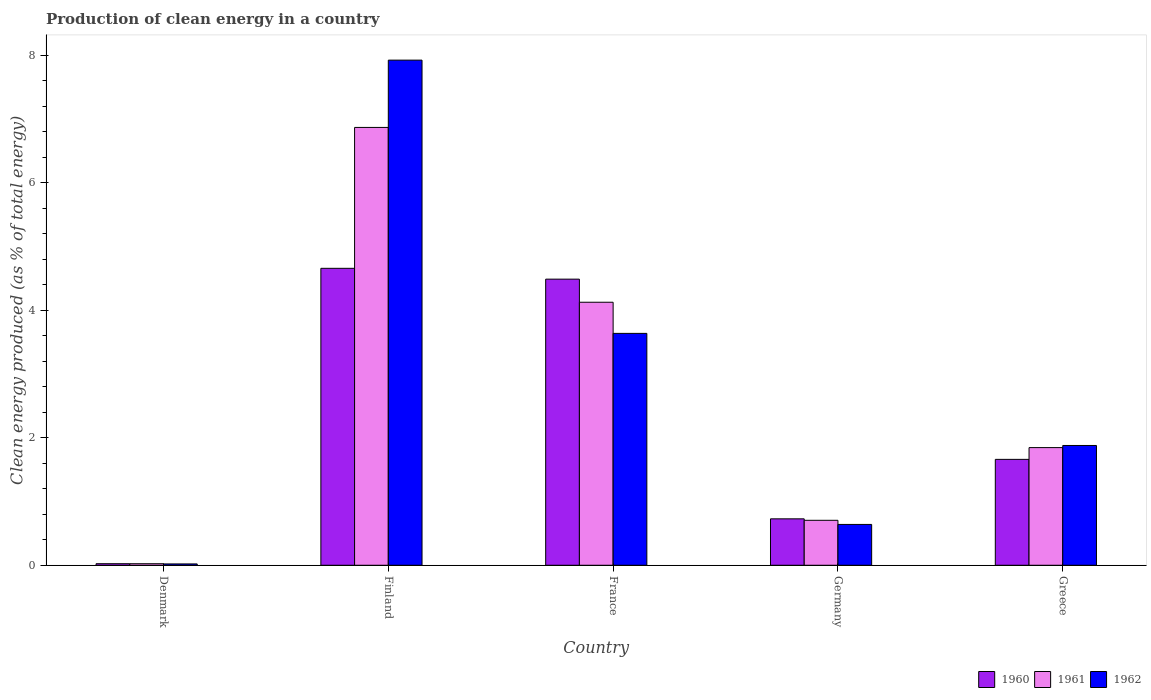Are the number of bars per tick equal to the number of legend labels?
Keep it short and to the point. Yes. How many bars are there on the 2nd tick from the right?
Make the answer very short. 3. What is the label of the 2nd group of bars from the left?
Offer a terse response. Finland. What is the percentage of clean energy produced in 1962 in Denmark?
Offer a terse response. 0.02. Across all countries, what is the maximum percentage of clean energy produced in 1961?
Your answer should be very brief. 6.87. Across all countries, what is the minimum percentage of clean energy produced in 1960?
Your response must be concise. 0.02. What is the total percentage of clean energy produced in 1962 in the graph?
Make the answer very short. 14.1. What is the difference between the percentage of clean energy produced in 1962 in France and that in Greece?
Your answer should be compact. 1.76. What is the difference between the percentage of clean energy produced in 1960 in Greece and the percentage of clean energy produced in 1962 in Denmark?
Keep it short and to the point. 1.64. What is the average percentage of clean energy produced in 1962 per country?
Make the answer very short. 2.82. What is the difference between the percentage of clean energy produced of/in 1960 and percentage of clean energy produced of/in 1962 in France?
Give a very brief answer. 0.85. In how many countries, is the percentage of clean energy produced in 1961 greater than 4.8 %?
Your response must be concise. 1. What is the ratio of the percentage of clean energy produced in 1961 in Denmark to that in Greece?
Your response must be concise. 0.01. What is the difference between the highest and the second highest percentage of clean energy produced in 1960?
Make the answer very short. -3. What is the difference between the highest and the lowest percentage of clean energy produced in 1962?
Offer a terse response. 7.9. Is the sum of the percentage of clean energy produced in 1962 in Finland and Germany greater than the maximum percentage of clean energy produced in 1960 across all countries?
Your response must be concise. Yes. What does the 1st bar from the right in Finland represents?
Offer a very short reply. 1962. How many bars are there?
Offer a terse response. 15. Are all the bars in the graph horizontal?
Keep it short and to the point. No. How many countries are there in the graph?
Your answer should be very brief. 5. Are the values on the major ticks of Y-axis written in scientific E-notation?
Your response must be concise. No. Does the graph contain grids?
Provide a short and direct response. No. Where does the legend appear in the graph?
Your answer should be very brief. Bottom right. How are the legend labels stacked?
Make the answer very short. Horizontal. What is the title of the graph?
Make the answer very short. Production of clean energy in a country. What is the label or title of the X-axis?
Provide a short and direct response. Country. What is the label or title of the Y-axis?
Your response must be concise. Clean energy produced (as % of total energy). What is the Clean energy produced (as % of total energy) in 1960 in Denmark?
Provide a succinct answer. 0.02. What is the Clean energy produced (as % of total energy) in 1961 in Denmark?
Keep it short and to the point. 0.02. What is the Clean energy produced (as % of total energy) of 1962 in Denmark?
Keep it short and to the point. 0.02. What is the Clean energy produced (as % of total energy) in 1960 in Finland?
Your response must be concise. 4.66. What is the Clean energy produced (as % of total energy) in 1961 in Finland?
Provide a succinct answer. 6.87. What is the Clean energy produced (as % of total energy) in 1962 in Finland?
Ensure brevity in your answer.  7.92. What is the Clean energy produced (as % of total energy) in 1960 in France?
Ensure brevity in your answer.  4.49. What is the Clean energy produced (as % of total energy) in 1961 in France?
Your answer should be very brief. 4.12. What is the Clean energy produced (as % of total energy) of 1962 in France?
Make the answer very short. 3.64. What is the Clean energy produced (as % of total energy) in 1960 in Germany?
Offer a terse response. 0.73. What is the Clean energy produced (as % of total energy) in 1961 in Germany?
Your response must be concise. 0.7. What is the Clean energy produced (as % of total energy) of 1962 in Germany?
Offer a very short reply. 0.64. What is the Clean energy produced (as % of total energy) of 1960 in Greece?
Make the answer very short. 1.66. What is the Clean energy produced (as % of total energy) of 1961 in Greece?
Give a very brief answer. 1.84. What is the Clean energy produced (as % of total energy) in 1962 in Greece?
Offer a terse response. 1.88. Across all countries, what is the maximum Clean energy produced (as % of total energy) in 1960?
Offer a terse response. 4.66. Across all countries, what is the maximum Clean energy produced (as % of total energy) in 1961?
Provide a short and direct response. 6.87. Across all countries, what is the maximum Clean energy produced (as % of total energy) of 1962?
Offer a very short reply. 7.92. Across all countries, what is the minimum Clean energy produced (as % of total energy) in 1960?
Make the answer very short. 0.02. Across all countries, what is the minimum Clean energy produced (as % of total energy) in 1961?
Make the answer very short. 0.02. Across all countries, what is the minimum Clean energy produced (as % of total energy) of 1962?
Give a very brief answer. 0.02. What is the total Clean energy produced (as % of total energy) in 1960 in the graph?
Keep it short and to the point. 11.56. What is the total Clean energy produced (as % of total energy) of 1961 in the graph?
Your response must be concise. 13.56. What is the total Clean energy produced (as % of total energy) of 1962 in the graph?
Provide a short and direct response. 14.1. What is the difference between the Clean energy produced (as % of total energy) of 1960 in Denmark and that in Finland?
Keep it short and to the point. -4.63. What is the difference between the Clean energy produced (as % of total energy) in 1961 in Denmark and that in Finland?
Provide a short and direct response. -6.84. What is the difference between the Clean energy produced (as % of total energy) in 1962 in Denmark and that in Finland?
Offer a very short reply. -7.9. What is the difference between the Clean energy produced (as % of total energy) in 1960 in Denmark and that in France?
Your response must be concise. -4.46. What is the difference between the Clean energy produced (as % of total energy) in 1961 in Denmark and that in France?
Give a very brief answer. -4.1. What is the difference between the Clean energy produced (as % of total energy) of 1962 in Denmark and that in France?
Your answer should be compact. -3.62. What is the difference between the Clean energy produced (as % of total energy) in 1960 in Denmark and that in Germany?
Make the answer very short. -0.7. What is the difference between the Clean energy produced (as % of total energy) of 1961 in Denmark and that in Germany?
Ensure brevity in your answer.  -0.68. What is the difference between the Clean energy produced (as % of total energy) of 1962 in Denmark and that in Germany?
Your answer should be compact. -0.62. What is the difference between the Clean energy produced (as % of total energy) of 1960 in Denmark and that in Greece?
Your answer should be compact. -1.64. What is the difference between the Clean energy produced (as % of total energy) in 1961 in Denmark and that in Greece?
Offer a terse response. -1.82. What is the difference between the Clean energy produced (as % of total energy) of 1962 in Denmark and that in Greece?
Provide a succinct answer. -1.86. What is the difference between the Clean energy produced (as % of total energy) of 1960 in Finland and that in France?
Your answer should be very brief. 0.17. What is the difference between the Clean energy produced (as % of total energy) in 1961 in Finland and that in France?
Your answer should be compact. 2.74. What is the difference between the Clean energy produced (as % of total energy) of 1962 in Finland and that in France?
Give a very brief answer. 4.28. What is the difference between the Clean energy produced (as % of total energy) of 1960 in Finland and that in Germany?
Your answer should be compact. 3.93. What is the difference between the Clean energy produced (as % of total energy) in 1961 in Finland and that in Germany?
Make the answer very short. 6.16. What is the difference between the Clean energy produced (as % of total energy) in 1962 in Finland and that in Germany?
Your answer should be very brief. 7.28. What is the difference between the Clean energy produced (as % of total energy) in 1960 in Finland and that in Greece?
Keep it short and to the point. 3. What is the difference between the Clean energy produced (as % of total energy) of 1961 in Finland and that in Greece?
Your answer should be compact. 5.02. What is the difference between the Clean energy produced (as % of total energy) in 1962 in Finland and that in Greece?
Offer a very short reply. 6.04. What is the difference between the Clean energy produced (as % of total energy) of 1960 in France and that in Germany?
Provide a short and direct response. 3.76. What is the difference between the Clean energy produced (as % of total energy) of 1961 in France and that in Germany?
Offer a terse response. 3.42. What is the difference between the Clean energy produced (as % of total energy) of 1962 in France and that in Germany?
Your response must be concise. 3. What is the difference between the Clean energy produced (as % of total energy) in 1960 in France and that in Greece?
Your answer should be very brief. 2.83. What is the difference between the Clean energy produced (as % of total energy) of 1961 in France and that in Greece?
Ensure brevity in your answer.  2.28. What is the difference between the Clean energy produced (as % of total energy) of 1962 in France and that in Greece?
Offer a very short reply. 1.76. What is the difference between the Clean energy produced (as % of total energy) of 1960 in Germany and that in Greece?
Keep it short and to the point. -0.93. What is the difference between the Clean energy produced (as % of total energy) of 1961 in Germany and that in Greece?
Your answer should be compact. -1.14. What is the difference between the Clean energy produced (as % of total energy) of 1962 in Germany and that in Greece?
Provide a succinct answer. -1.24. What is the difference between the Clean energy produced (as % of total energy) in 1960 in Denmark and the Clean energy produced (as % of total energy) in 1961 in Finland?
Ensure brevity in your answer.  -6.84. What is the difference between the Clean energy produced (as % of total energy) in 1960 in Denmark and the Clean energy produced (as % of total energy) in 1962 in Finland?
Give a very brief answer. -7.9. What is the difference between the Clean energy produced (as % of total energy) in 1961 in Denmark and the Clean energy produced (as % of total energy) in 1962 in Finland?
Ensure brevity in your answer.  -7.9. What is the difference between the Clean energy produced (as % of total energy) of 1960 in Denmark and the Clean energy produced (as % of total energy) of 1961 in France?
Offer a terse response. -4.1. What is the difference between the Clean energy produced (as % of total energy) of 1960 in Denmark and the Clean energy produced (as % of total energy) of 1962 in France?
Give a very brief answer. -3.61. What is the difference between the Clean energy produced (as % of total energy) in 1961 in Denmark and the Clean energy produced (as % of total energy) in 1962 in France?
Your answer should be compact. -3.61. What is the difference between the Clean energy produced (as % of total energy) of 1960 in Denmark and the Clean energy produced (as % of total energy) of 1961 in Germany?
Your answer should be very brief. -0.68. What is the difference between the Clean energy produced (as % of total energy) of 1960 in Denmark and the Clean energy produced (as % of total energy) of 1962 in Germany?
Keep it short and to the point. -0.62. What is the difference between the Clean energy produced (as % of total energy) in 1961 in Denmark and the Clean energy produced (as % of total energy) in 1962 in Germany?
Provide a succinct answer. -0.62. What is the difference between the Clean energy produced (as % of total energy) of 1960 in Denmark and the Clean energy produced (as % of total energy) of 1961 in Greece?
Your answer should be very brief. -1.82. What is the difference between the Clean energy produced (as % of total energy) of 1960 in Denmark and the Clean energy produced (as % of total energy) of 1962 in Greece?
Offer a very short reply. -1.85. What is the difference between the Clean energy produced (as % of total energy) in 1961 in Denmark and the Clean energy produced (as % of total energy) in 1962 in Greece?
Provide a short and direct response. -1.85. What is the difference between the Clean energy produced (as % of total energy) in 1960 in Finland and the Clean energy produced (as % of total energy) in 1961 in France?
Ensure brevity in your answer.  0.53. What is the difference between the Clean energy produced (as % of total energy) of 1960 in Finland and the Clean energy produced (as % of total energy) of 1962 in France?
Offer a very short reply. 1.02. What is the difference between the Clean energy produced (as % of total energy) of 1961 in Finland and the Clean energy produced (as % of total energy) of 1962 in France?
Your answer should be compact. 3.23. What is the difference between the Clean energy produced (as % of total energy) of 1960 in Finland and the Clean energy produced (as % of total energy) of 1961 in Germany?
Ensure brevity in your answer.  3.95. What is the difference between the Clean energy produced (as % of total energy) of 1960 in Finland and the Clean energy produced (as % of total energy) of 1962 in Germany?
Offer a very short reply. 4.02. What is the difference between the Clean energy produced (as % of total energy) in 1961 in Finland and the Clean energy produced (as % of total energy) in 1962 in Germany?
Ensure brevity in your answer.  6.23. What is the difference between the Clean energy produced (as % of total energy) in 1960 in Finland and the Clean energy produced (as % of total energy) in 1961 in Greece?
Ensure brevity in your answer.  2.81. What is the difference between the Clean energy produced (as % of total energy) of 1960 in Finland and the Clean energy produced (as % of total energy) of 1962 in Greece?
Your response must be concise. 2.78. What is the difference between the Clean energy produced (as % of total energy) in 1961 in Finland and the Clean energy produced (as % of total energy) in 1962 in Greece?
Offer a terse response. 4.99. What is the difference between the Clean energy produced (as % of total energy) of 1960 in France and the Clean energy produced (as % of total energy) of 1961 in Germany?
Offer a very short reply. 3.78. What is the difference between the Clean energy produced (as % of total energy) of 1960 in France and the Clean energy produced (as % of total energy) of 1962 in Germany?
Your answer should be very brief. 3.85. What is the difference between the Clean energy produced (as % of total energy) in 1961 in France and the Clean energy produced (as % of total energy) in 1962 in Germany?
Ensure brevity in your answer.  3.48. What is the difference between the Clean energy produced (as % of total energy) of 1960 in France and the Clean energy produced (as % of total energy) of 1961 in Greece?
Your answer should be compact. 2.64. What is the difference between the Clean energy produced (as % of total energy) in 1960 in France and the Clean energy produced (as % of total energy) in 1962 in Greece?
Provide a succinct answer. 2.61. What is the difference between the Clean energy produced (as % of total energy) of 1961 in France and the Clean energy produced (as % of total energy) of 1962 in Greece?
Give a very brief answer. 2.25. What is the difference between the Clean energy produced (as % of total energy) of 1960 in Germany and the Clean energy produced (as % of total energy) of 1961 in Greece?
Ensure brevity in your answer.  -1.12. What is the difference between the Clean energy produced (as % of total energy) in 1960 in Germany and the Clean energy produced (as % of total energy) in 1962 in Greece?
Make the answer very short. -1.15. What is the difference between the Clean energy produced (as % of total energy) of 1961 in Germany and the Clean energy produced (as % of total energy) of 1962 in Greece?
Offer a very short reply. -1.17. What is the average Clean energy produced (as % of total energy) of 1960 per country?
Keep it short and to the point. 2.31. What is the average Clean energy produced (as % of total energy) in 1961 per country?
Provide a succinct answer. 2.71. What is the average Clean energy produced (as % of total energy) in 1962 per country?
Offer a terse response. 2.82. What is the difference between the Clean energy produced (as % of total energy) of 1960 and Clean energy produced (as % of total energy) of 1961 in Denmark?
Offer a terse response. 0. What is the difference between the Clean energy produced (as % of total energy) in 1960 and Clean energy produced (as % of total energy) in 1962 in Denmark?
Make the answer very short. 0. What is the difference between the Clean energy produced (as % of total energy) of 1961 and Clean energy produced (as % of total energy) of 1962 in Denmark?
Give a very brief answer. 0. What is the difference between the Clean energy produced (as % of total energy) in 1960 and Clean energy produced (as % of total energy) in 1961 in Finland?
Offer a terse response. -2.21. What is the difference between the Clean energy produced (as % of total energy) in 1960 and Clean energy produced (as % of total energy) in 1962 in Finland?
Ensure brevity in your answer.  -3.26. What is the difference between the Clean energy produced (as % of total energy) in 1961 and Clean energy produced (as % of total energy) in 1962 in Finland?
Ensure brevity in your answer.  -1.06. What is the difference between the Clean energy produced (as % of total energy) in 1960 and Clean energy produced (as % of total energy) in 1961 in France?
Provide a succinct answer. 0.36. What is the difference between the Clean energy produced (as % of total energy) of 1960 and Clean energy produced (as % of total energy) of 1962 in France?
Provide a succinct answer. 0.85. What is the difference between the Clean energy produced (as % of total energy) of 1961 and Clean energy produced (as % of total energy) of 1962 in France?
Offer a terse response. 0.49. What is the difference between the Clean energy produced (as % of total energy) of 1960 and Clean energy produced (as % of total energy) of 1961 in Germany?
Keep it short and to the point. 0.02. What is the difference between the Clean energy produced (as % of total energy) of 1960 and Clean energy produced (as % of total energy) of 1962 in Germany?
Keep it short and to the point. 0.09. What is the difference between the Clean energy produced (as % of total energy) in 1961 and Clean energy produced (as % of total energy) in 1962 in Germany?
Offer a terse response. 0.06. What is the difference between the Clean energy produced (as % of total energy) in 1960 and Clean energy produced (as % of total energy) in 1961 in Greece?
Make the answer very short. -0.18. What is the difference between the Clean energy produced (as % of total energy) in 1960 and Clean energy produced (as % of total energy) in 1962 in Greece?
Offer a very short reply. -0.22. What is the difference between the Clean energy produced (as % of total energy) in 1961 and Clean energy produced (as % of total energy) in 1962 in Greece?
Offer a very short reply. -0.03. What is the ratio of the Clean energy produced (as % of total energy) in 1960 in Denmark to that in Finland?
Your answer should be compact. 0.01. What is the ratio of the Clean energy produced (as % of total energy) in 1961 in Denmark to that in Finland?
Your answer should be very brief. 0. What is the ratio of the Clean energy produced (as % of total energy) in 1962 in Denmark to that in Finland?
Your answer should be very brief. 0. What is the ratio of the Clean energy produced (as % of total energy) of 1960 in Denmark to that in France?
Give a very brief answer. 0.01. What is the ratio of the Clean energy produced (as % of total energy) of 1961 in Denmark to that in France?
Your response must be concise. 0.01. What is the ratio of the Clean energy produced (as % of total energy) in 1962 in Denmark to that in France?
Your answer should be compact. 0.01. What is the ratio of the Clean energy produced (as % of total energy) of 1960 in Denmark to that in Germany?
Make the answer very short. 0.03. What is the ratio of the Clean energy produced (as % of total energy) in 1961 in Denmark to that in Germany?
Your answer should be very brief. 0.03. What is the ratio of the Clean energy produced (as % of total energy) of 1962 in Denmark to that in Germany?
Offer a terse response. 0.03. What is the ratio of the Clean energy produced (as % of total energy) of 1960 in Denmark to that in Greece?
Your answer should be very brief. 0.01. What is the ratio of the Clean energy produced (as % of total energy) of 1961 in Denmark to that in Greece?
Your answer should be compact. 0.01. What is the ratio of the Clean energy produced (as % of total energy) in 1962 in Denmark to that in Greece?
Keep it short and to the point. 0.01. What is the ratio of the Clean energy produced (as % of total energy) in 1960 in Finland to that in France?
Your answer should be compact. 1.04. What is the ratio of the Clean energy produced (as % of total energy) in 1961 in Finland to that in France?
Provide a succinct answer. 1.66. What is the ratio of the Clean energy produced (as % of total energy) of 1962 in Finland to that in France?
Make the answer very short. 2.18. What is the ratio of the Clean energy produced (as % of total energy) in 1960 in Finland to that in Germany?
Your answer should be compact. 6.4. What is the ratio of the Clean energy produced (as % of total energy) in 1961 in Finland to that in Germany?
Provide a short and direct response. 9.74. What is the ratio of the Clean energy produced (as % of total energy) in 1962 in Finland to that in Germany?
Give a very brief answer. 12.37. What is the ratio of the Clean energy produced (as % of total energy) of 1960 in Finland to that in Greece?
Ensure brevity in your answer.  2.8. What is the ratio of the Clean energy produced (as % of total energy) of 1961 in Finland to that in Greece?
Ensure brevity in your answer.  3.72. What is the ratio of the Clean energy produced (as % of total energy) in 1962 in Finland to that in Greece?
Your response must be concise. 4.22. What is the ratio of the Clean energy produced (as % of total energy) in 1960 in France to that in Germany?
Make the answer very short. 6.16. What is the ratio of the Clean energy produced (as % of total energy) in 1961 in France to that in Germany?
Provide a succinct answer. 5.85. What is the ratio of the Clean energy produced (as % of total energy) in 1962 in France to that in Germany?
Offer a very short reply. 5.68. What is the ratio of the Clean energy produced (as % of total energy) of 1960 in France to that in Greece?
Your answer should be very brief. 2.7. What is the ratio of the Clean energy produced (as % of total energy) of 1961 in France to that in Greece?
Give a very brief answer. 2.24. What is the ratio of the Clean energy produced (as % of total energy) of 1962 in France to that in Greece?
Provide a short and direct response. 1.94. What is the ratio of the Clean energy produced (as % of total energy) of 1960 in Germany to that in Greece?
Provide a short and direct response. 0.44. What is the ratio of the Clean energy produced (as % of total energy) of 1961 in Germany to that in Greece?
Make the answer very short. 0.38. What is the ratio of the Clean energy produced (as % of total energy) of 1962 in Germany to that in Greece?
Offer a very short reply. 0.34. What is the difference between the highest and the second highest Clean energy produced (as % of total energy) in 1960?
Your response must be concise. 0.17. What is the difference between the highest and the second highest Clean energy produced (as % of total energy) in 1961?
Offer a very short reply. 2.74. What is the difference between the highest and the second highest Clean energy produced (as % of total energy) of 1962?
Your response must be concise. 4.28. What is the difference between the highest and the lowest Clean energy produced (as % of total energy) of 1960?
Make the answer very short. 4.63. What is the difference between the highest and the lowest Clean energy produced (as % of total energy) of 1961?
Make the answer very short. 6.84. What is the difference between the highest and the lowest Clean energy produced (as % of total energy) of 1962?
Keep it short and to the point. 7.9. 